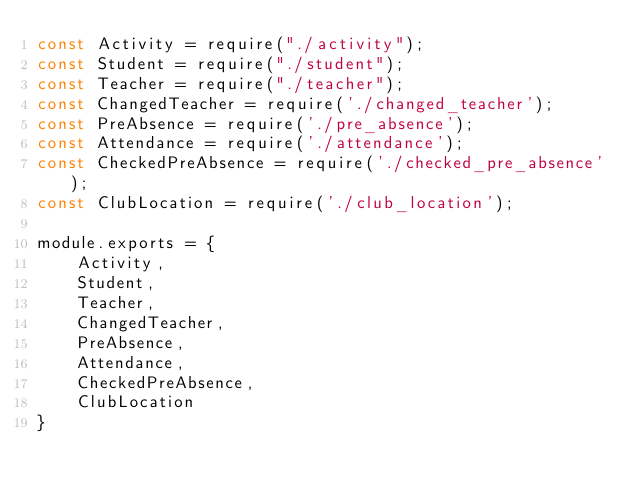Convert code to text. <code><loc_0><loc_0><loc_500><loc_500><_JavaScript_>const Activity = require("./activity");
const Student = require("./student");
const Teacher = require("./teacher");
const ChangedTeacher = require('./changed_teacher');
const PreAbsence = require('./pre_absence');
const Attendance = require('./attendance');
const CheckedPreAbsence = require('./checked_pre_absence');
const ClubLocation = require('./club_location');

module.exports = {
    Activity,
    Student,
    Teacher,
    ChangedTeacher,
    PreAbsence,
    Attendance,
    CheckedPreAbsence,
    ClubLocation
}</code> 